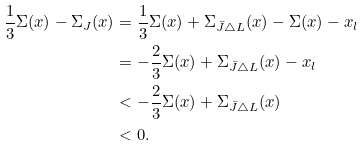<formula> <loc_0><loc_0><loc_500><loc_500>\frac { 1 } { 3 } \Sigma ( x ) - \Sigma _ { J } ( x ) & = \frac { 1 } { 3 } \Sigma ( x ) + \Sigma _ { \bar { J } \triangle L } ( x ) - \Sigma ( x ) - x _ { l } \\ & = - \frac { 2 } { 3 } \Sigma ( x ) + \Sigma _ { \bar { J } \triangle L } ( x ) - x _ { l } \\ & < - \frac { 2 } { 3 } \Sigma ( x ) + \Sigma _ { \bar { J } \triangle L } ( x ) \\ & < 0 .</formula> 